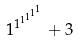Convert formula to latex. <formula><loc_0><loc_0><loc_500><loc_500>1 ^ { 1 ^ { 1 ^ { 1 ^ { 1 ^ { 1 } } } } } + 3</formula> 